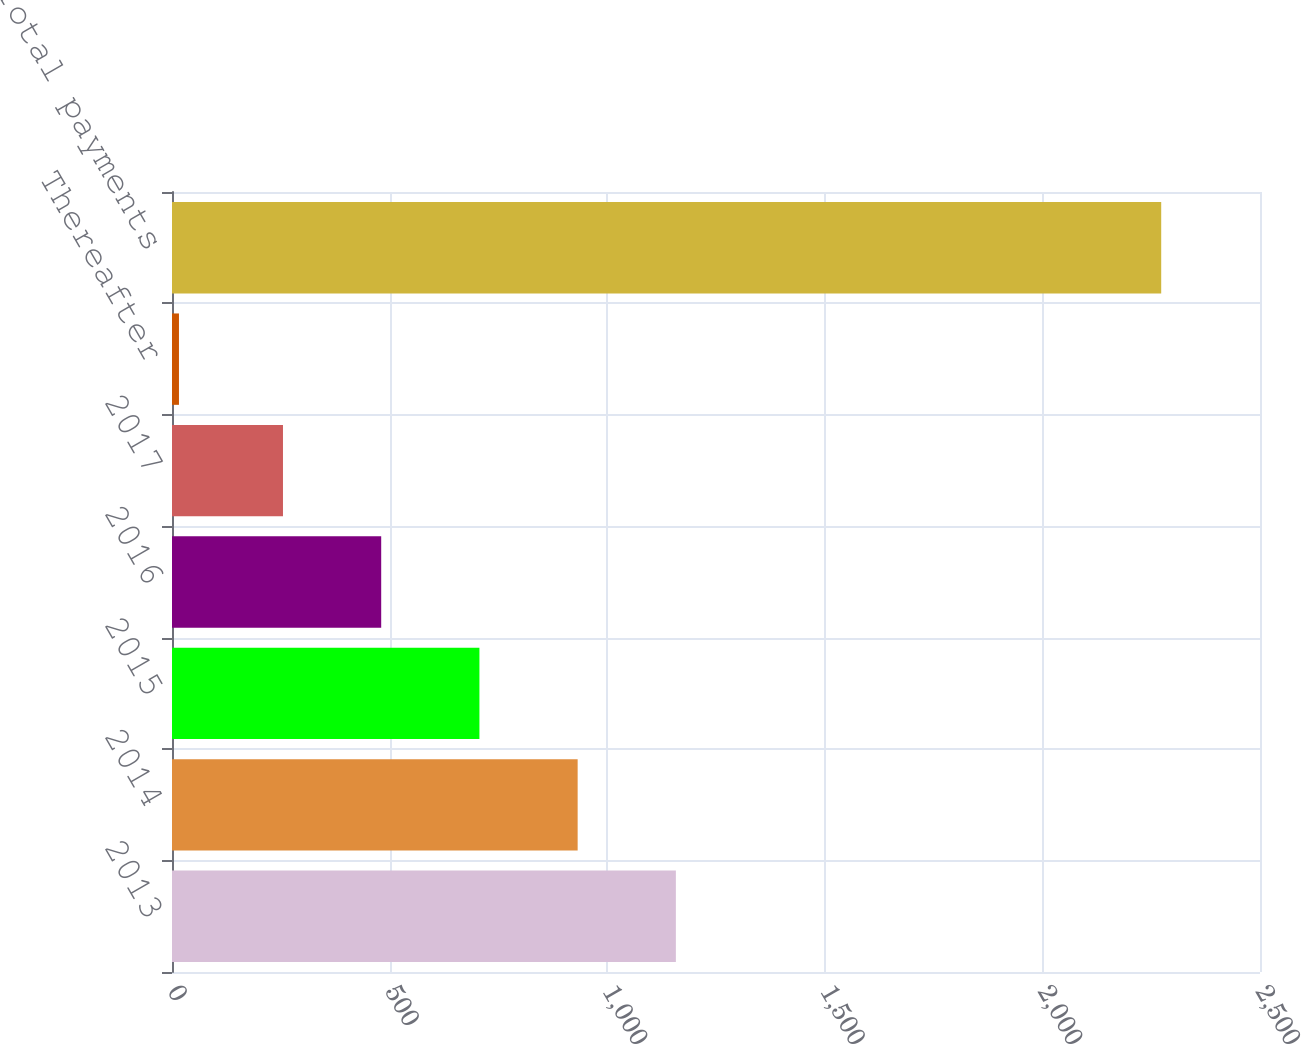Convert chart to OTSL. <chart><loc_0><loc_0><loc_500><loc_500><bar_chart><fcel>2013<fcel>2014<fcel>2015<fcel>2016<fcel>2017<fcel>Thereafter<fcel>Total payments<nl><fcel>1157.8<fcel>932.1<fcel>706.4<fcel>480.7<fcel>255<fcel>16<fcel>2273<nl></chart> 